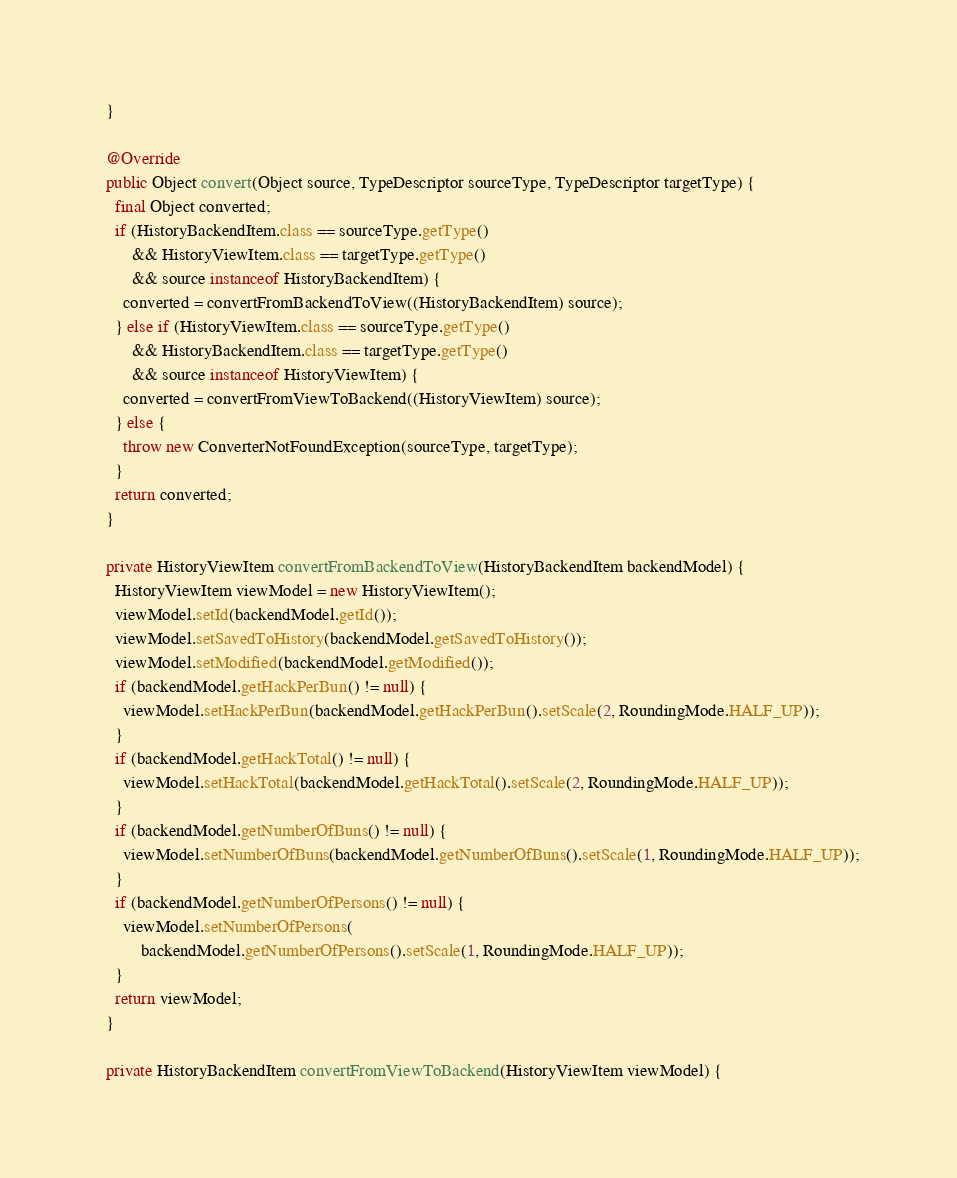Convert code to text. <code><loc_0><loc_0><loc_500><loc_500><_Java_>  }

  @Override
  public Object convert(Object source, TypeDescriptor sourceType, TypeDescriptor targetType) {
    final Object converted;
    if (HistoryBackendItem.class == sourceType.getType()
        && HistoryViewItem.class == targetType.getType()
        && source instanceof HistoryBackendItem) {
      converted = convertFromBackendToView((HistoryBackendItem) source);
    } else if (HistoryViewItem.class == sourceType.getType()
        && HistoryBackendItem.class == targetType.getType()
        && source instanceof HistoryViewItem) {
      converted = convertFromViewToBackend((HistoryViewItem) source);
    } else {
      throw new ConverterNotFoundException(sourceType, targetType);
    }
    return converted;
  }

  private HistoryViewItem convertFromBackendToView(HistoryBackendItem backendModel) {
    HistoryViewItem viewModel = new HistoryViewItem();
    viewModel.setId(backendModel.getId());
    viewModel.setSavedToHistory(backendModel.getSavedToHistory());
    viewModel.setModified(backendModel.getModified());
    if (backendModel.getHackPerBun() != null) {
      viewModel.setHackPerBun(backendModel.getHackPerBun().setScale(2, RoundingMode.HALF_UP));
    }
    if (backendModel.getHackTotal() != null) {
      viewModel.setHackTotal(backendModel.getHackTotal().setScale(2, RoundingMode.HALF_UP));
    }
    if (backendModel.getNumberOfBuns() != null) {
      viewModel.setNumberOfBuns(backendModel.getNumberOfBuns().setScale(1, RoundingMode.HALF_UP));
    }
    if (backendModel.getNumberOfPersons() != null) {
      viewModel.setNumberOfPersons(
          backendModel.getNumberOfPersons().setScale(1, RoundingMode.HALF_UP));
    }
    return viewModel;
  }

  private HistoryBackendItem convertFromViewToBackend(HistoryViewItem viewModel) {</code> 